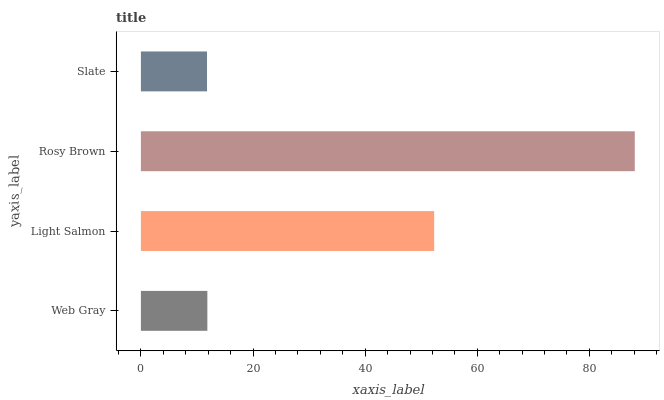Is Slate the minimum?
Answer yes or no. Yes. Is Rosy Brown the maximum?
Answer yes or no. Yes. Is Light Salmon the minimum?
Answer yes or no. No. Is Light Salmon the maximum?
Answer yes or no. No. Is Light Salmon greater than Web Gray?
Answer yes or no. Yes. Is Web Gray less than Light Salmon?
Answer yes or no. Yes. Is Web Gray greater than Light Salmon?
Answer yes or no. No. Is Light Salmon less than Web Gray?
Answer yes or no. No. Is Light Salmon the high median?
Answer yes or no. Yes. Is Web Gray the low median?
Answer yes or no. Yes. Is Slate the high median?
Answer yes or no. No. Is Slate the low median?
Answer yes or no. No. 